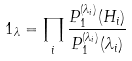Convert formula to latex. <formula><loc_0><loc_0><loc_500><loc_500>1 _ { \lambda } = \prod _ { i } \frac { P ^ { ( \lambda _ { i } ) } _ { 1 } ( H _ { i } ) } { P ^ { ( \lambda _ { i } ) } _ { 1 } ( \lambda _ { i } ) }</formula> 